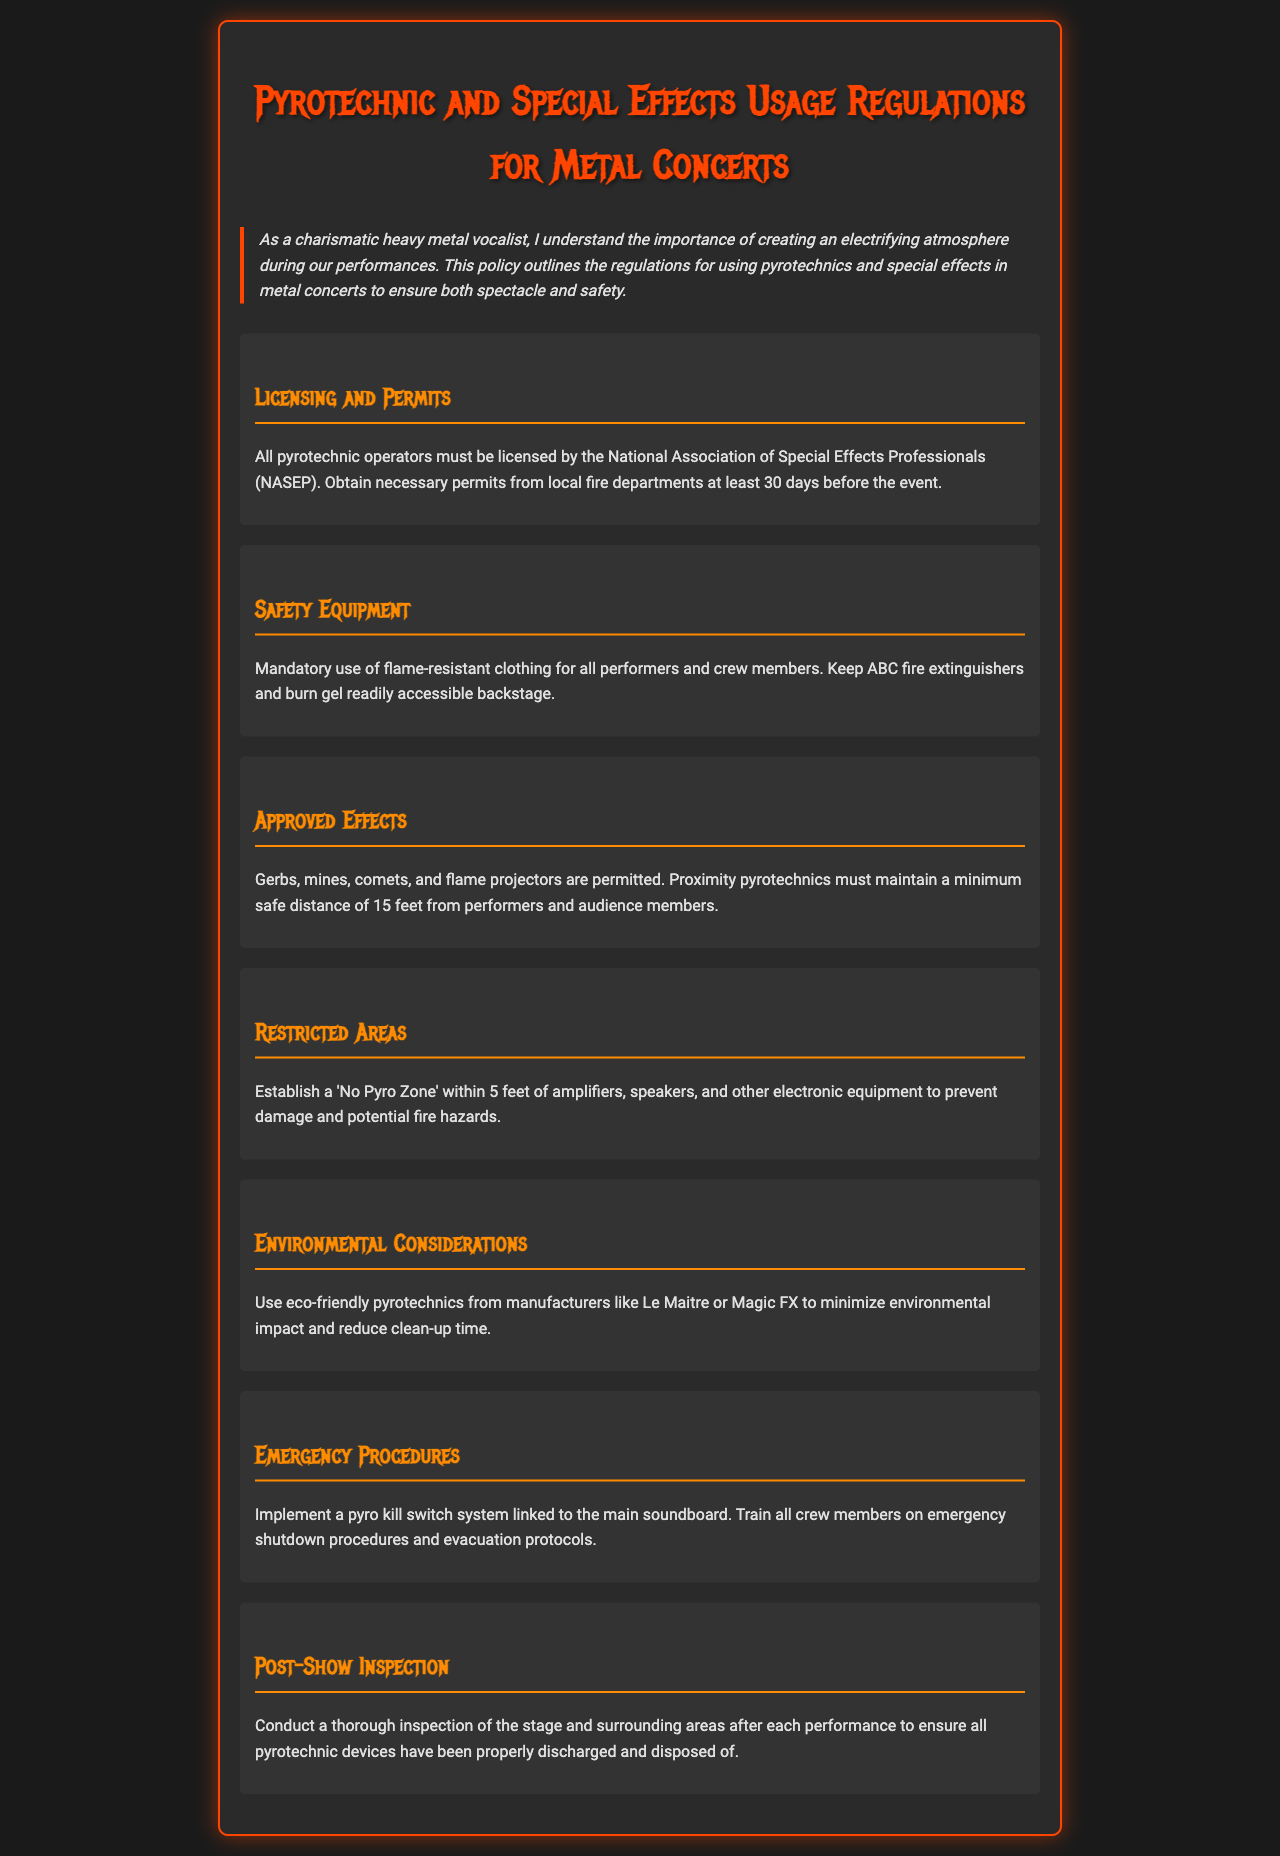What organization licenses pyrotechnic operators? The document states that all pyrotechnic operators must be licensed by the National Association of Special Effects Professionals.
Answer: National Association of Special Effects Professionals How many days before the event should permits be obtained? According to the regulations, necessary permits must be obtained from local fire departments at least 30 days before the event.
Answer: 30 days What type of fire extinguishers should be kept accessible? The policy specifies that ABC fire extinguishers should be readily accessible backstage.
Answer: ABC fire extinguishers What is the minimum safe distance for proximity pyrotechnics? The document specifies that proximity pyrotechnics must maintain a minimum safe distance of 15 feet from performers and audience members.
Answer: 15 feet What are the approved types of pyrotechnics? Approved effects mentioned in the document include gerbs, mines, comets, and flame projectors.
Answer: Gerbs, mines, comets, flame projectors What is prohibited within 5 feet of electronic equipment? The document establishes a 'No Pyro Zone' within 5 feet of amplifiers, speakers, and other electronic equipment.
Answer: No Pyro Zone What type of manufacturers should be used for eco-friendly pyrotechnics? The policy encourages the use of eco-friendly pyrotechnics from manufacturers like Le Maitre or Magic FX.
Answer: Le Maitre or Magic FX What system should be implemented for emergency procedures? The document states to implement a pyro kill switch system linked to the main soundboard.
Answer: Pyro kill switch system What is the main focus of the post-show inspection? After the performance, the focus is to ensure all pyrotechnic devices have been properly discharged and disposed of.
Answer: Properly discharged and disposed of 